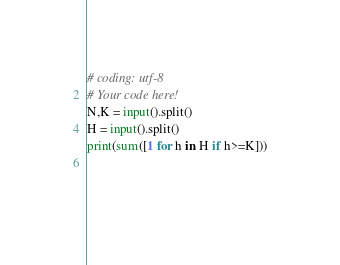Convert code to text. <code><loc_0><loc_0><loc_500><loc_500><_Python_># coding: utf-8
# Your code here!
N,K = input().split()
H = input().split()
print(sum([1 for h in H if h>=K]))

    





</code> 